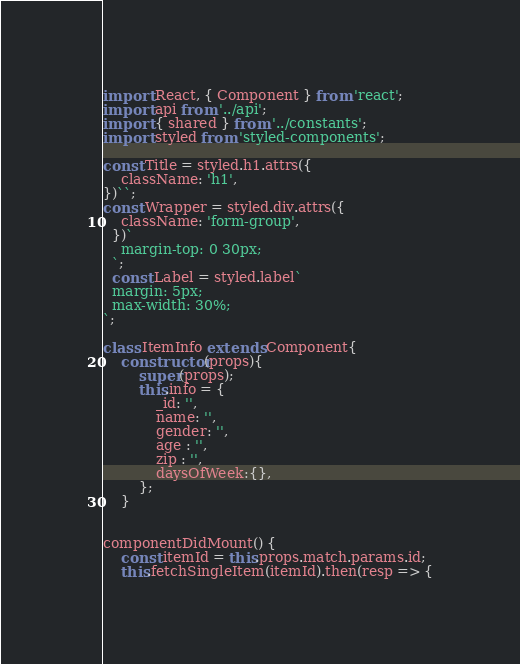Convert code to text. <code><loc_0><loc_0><loc_500><loc_500><_JavaScript_>import React, { Component } from 'react';
import api from '../api';
import { shared } from '../constants';
import styled from 'styled-components';

const Title = styled.h1.attrs({
    className: 'h1',
})``;
const Wrapper = styled.div.attrs({
    className: 'form-group',
  })`
    margin-top: 0 30px;
  `;
  const Label = styled.label`
  margin: 5px;
  max-width: 30%;
`;
  
class ItemInfo extends Component{
    constructor(props){
        super(props);
        this.info = {
            _id: '',
            name: '',
            gender: '',
            age : '',
            zip : '',
            daysOfWeek:{},
        };
    }


componentDidMount() {
    const itemId = this.props.match.params.id;
    this.fetchSingleItem(itemId).then(resp => {</code> 